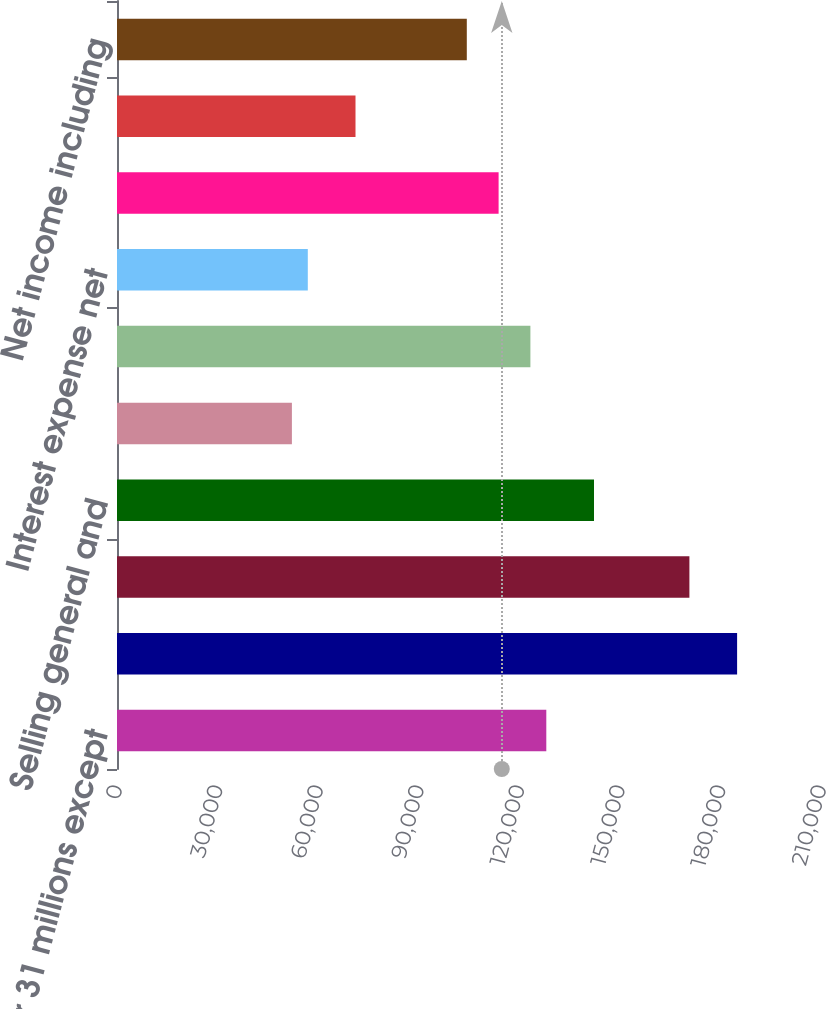Convert chart. <chart><loc_0><loc_0><loc_500><loc_500><bar_chart><fcel>December 31 millions except<fcel>Net sales<fcel>Cost of sales (including<fcel>Selling general and<fcel>Special (gains) and charges<fcel>Operating income<fcel>Interest expense net<fcel>Income before income taxes<fcel>Provision for income taxes<fcel>Net income including<nl><fcel>128059<fcel>184973<fcel>170745<fcel>142288<fcel>52172.8<fcel>123316<fcel>56915.7<fcel>113830<fcel>71144.4<fcel>104345<nl></chart> 